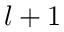<formula> <loc_0><loc_0><loc_500><loc_500>l + 1</formula> 